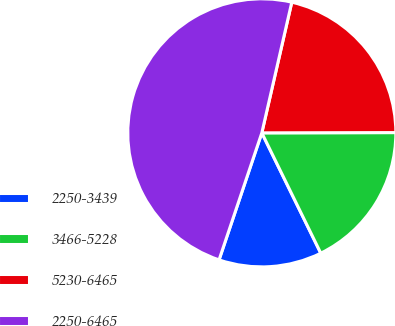Convert chart. <chart><loc_0><loc_0><loc_500><loc_500><pie_chart><fcel>2250-3439<fcel>3466-5228<fcel>5230-6465<fcel>2250-6465<nl><fcel>12.42%<fcel>17.78%<fcel>21.38%<fcel>48.42%<nl></chart> 